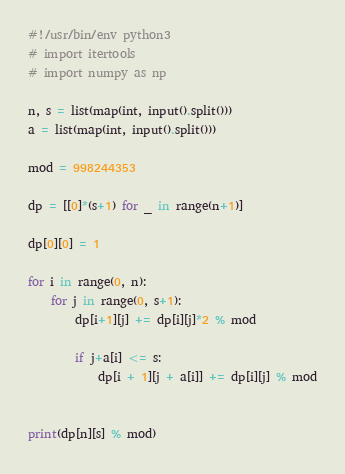Convert code to text. <code><loc_0><loc_0><loc_500><loc_500><_Cython_>#!/usr/bin/env python3
# import itertools
# import numpy as np

n, s = list(map(int, input().split()))
a = list(map(int, input().split()))

mod = 998244353

dp = [[0]*(s+1) for _ in range(n+1)]

dp[0][0] = 1

for i in range(0, n):
    for j in range(0, s+1):
        dp[i+1][j] += dp[i][j]*2 % mod

        if j+a[i] <= s:
            dp[i + 1][j + a[i]] += dp[i][j] % mod


print(dp[n][s] % mod)
</code> 